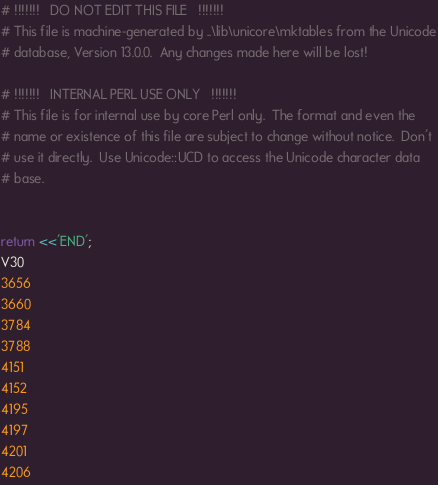Convert code to text. <code><loc_0><loc_0><loc_500><loc_500><_Perl_># !!!!!!!   DO NOT EDIT THIS FILE   !!!!!!!
# This file is machine-generated by ..\lib\unicore\mktables from the Unicode
# database, Version 13.0.0.  Any changes made here will be lost!

# !!!!!!!   INTERNAL PERL USE ONLY   !!!!!!!
# This file is for internal use by core Perl only.  The format and even the
# name or existence of this file are subject to change without notice.  Don't
# use it directly.  Use Unicode::UCD to access the Unicode character data
# base.


return <<'END';
V30
3656
3660
3784
3788
4151
4152
4195
4197
4201
4206</code> 